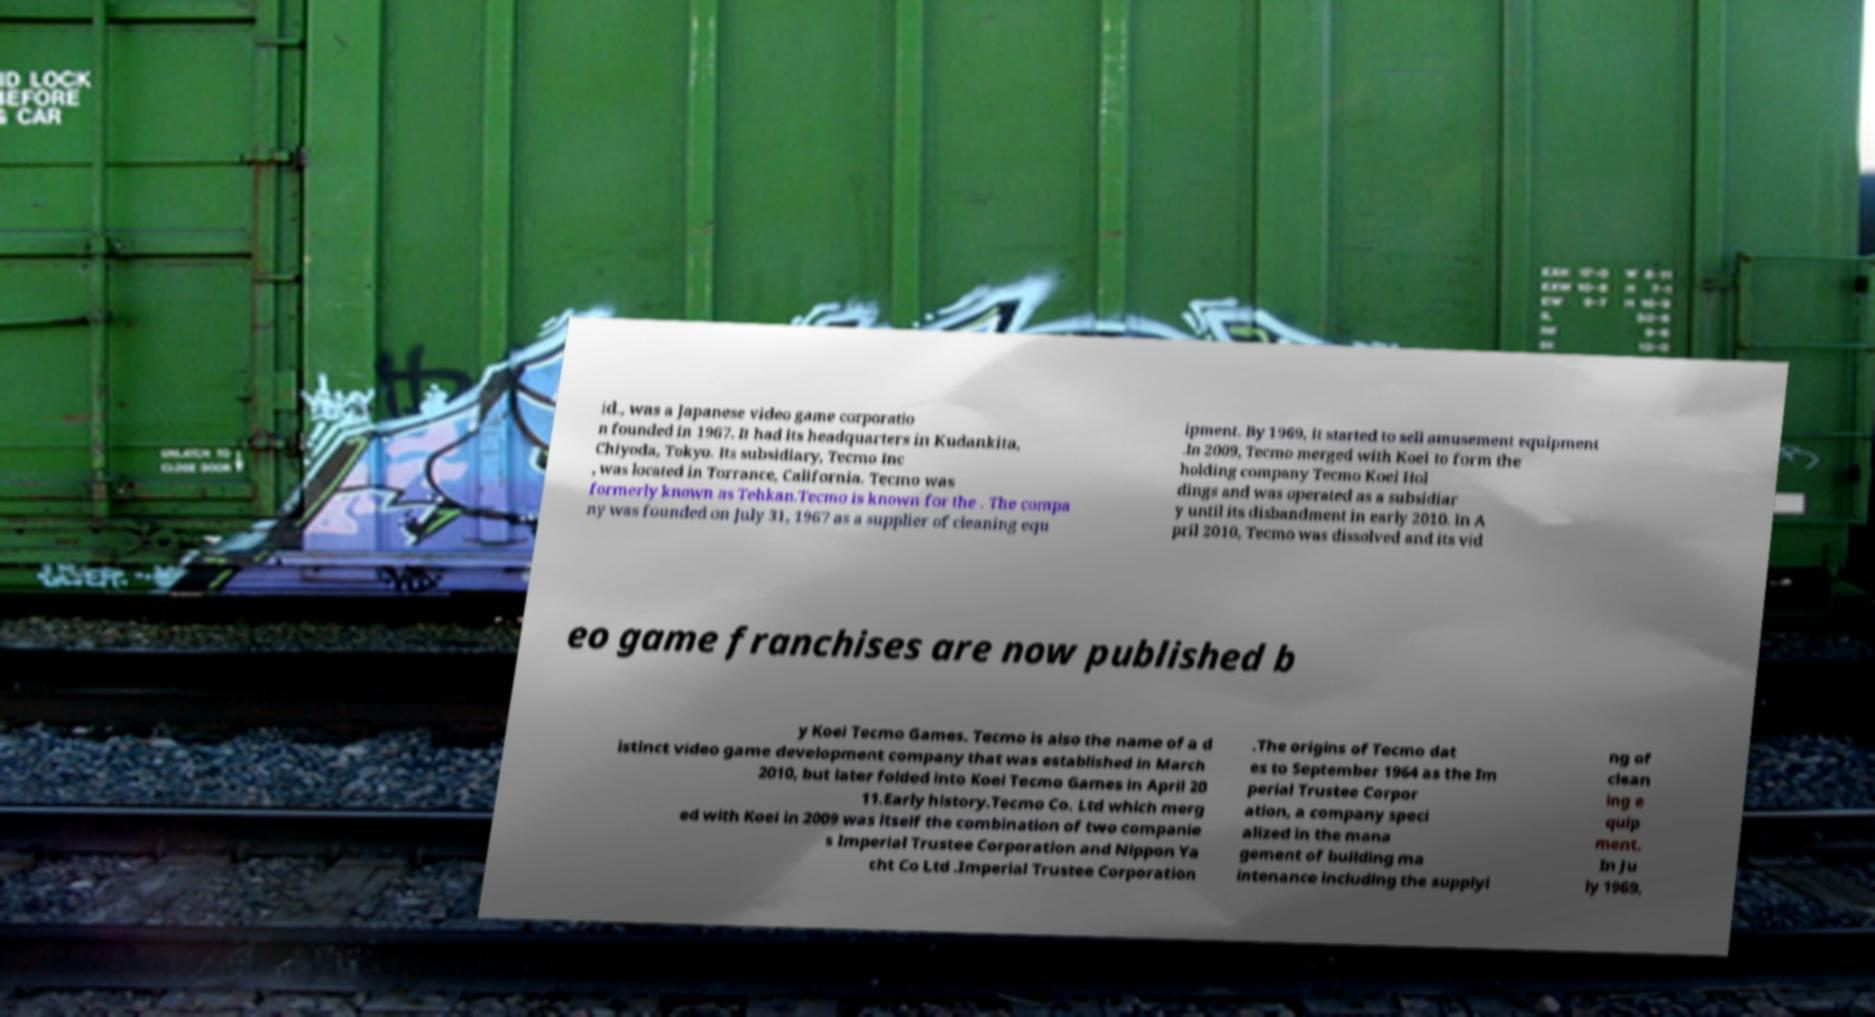Could you extract and type out the text from this image? id., was a Japanese video game corporatio n founded in 1967. It had its headquarters in Kudankita, Chiyoda, Tokyo. Its subsidiary, Tecmo Inc , was located in Torrance, California. Tecmo was formerly known as Tehkan.Tecmo is known for the . The compa ny was founded on July 31, 1967 as a supplier of cleaning equ ipment. By 1969, it started to sell amusement equipment .In 2009, Tecmo merged with Koei to form the holding company Tecmo Koei Hol dings and was operated as a subsidiar y until its disbandment in early 2010. In A pril 2010, Tecmo was dissolved and its vid eo game franchises are now published b y Koei Tecmo Games. Tecmo is also the name of a d istinct video game development company that was established in March 2010, but later folded into Koei Tecmo Games in April 20 11.Early history.Tecmo Co. Ltd which merg ed with Koei in 2009 was itself the combination of two companie s Imperial Trustee Corporation and Nippon Ya cht Co Ltd .Imperial Trustee Corporation .The origins of Tecmo dat es to September 1964 as the Im perial Trustee Corpor ation, a company speci alized in the mana gement of building ma intenance including the supplyi ng of clean ing e quip ment. In Ju ly 1969, 